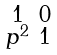<formula> <loc_0><loc_0><loc_500><loc_500>\begin{smallmatrix} 1 & 0 \\ p ^ { 2 } & 1 \\ \end{smallmatrix}</formula> 